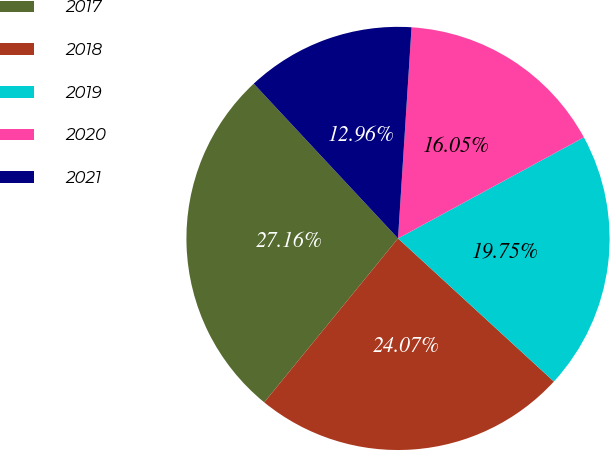Convert chart to OTSL. <chart><loc_0><loc_0><loc_500><loc_500><pie_chart><fcel>2017<fcel>2018<fcel>2019<fcel>2020<fcel>2021<nl><fcel>27.16%<fcel>24.07%<fcel>19.75%<fcel>16.05%<fcel>12.96%<nl></chart> 